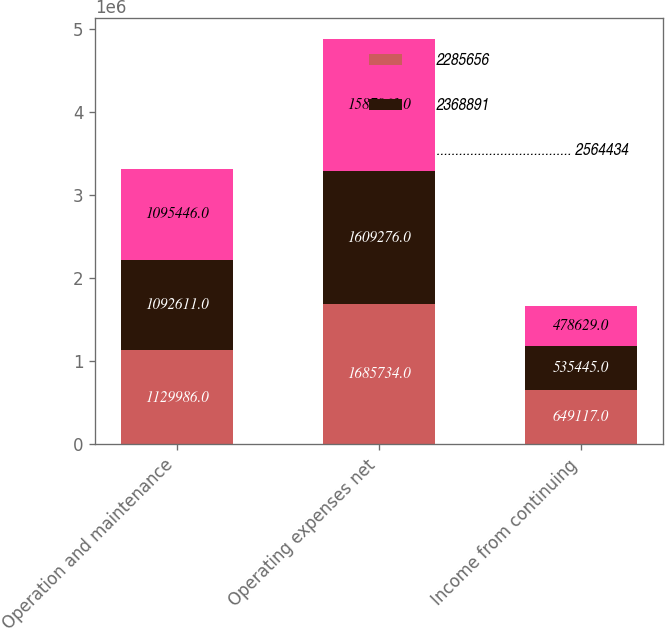<chart> <loc_0><loc_0><loc_500><loc_500><stacked_bar_chart><ecel><fcel>Operation and maintenance<fcel>Operating expenses net<fcel>Income from continuing<nl><fcel>2285656<fcel>1.12999e+06<fcel>1.68573e+06<fcel>649117<nl><fcel>2368891<fcel>1.09261e+06<fcel>1.60928e+06<fcel>535445<nl><fcel>.................................... 2564434<fcel>1.09545e+06<fcel>1.58796e+06<fcel>478629<nl></chart> 